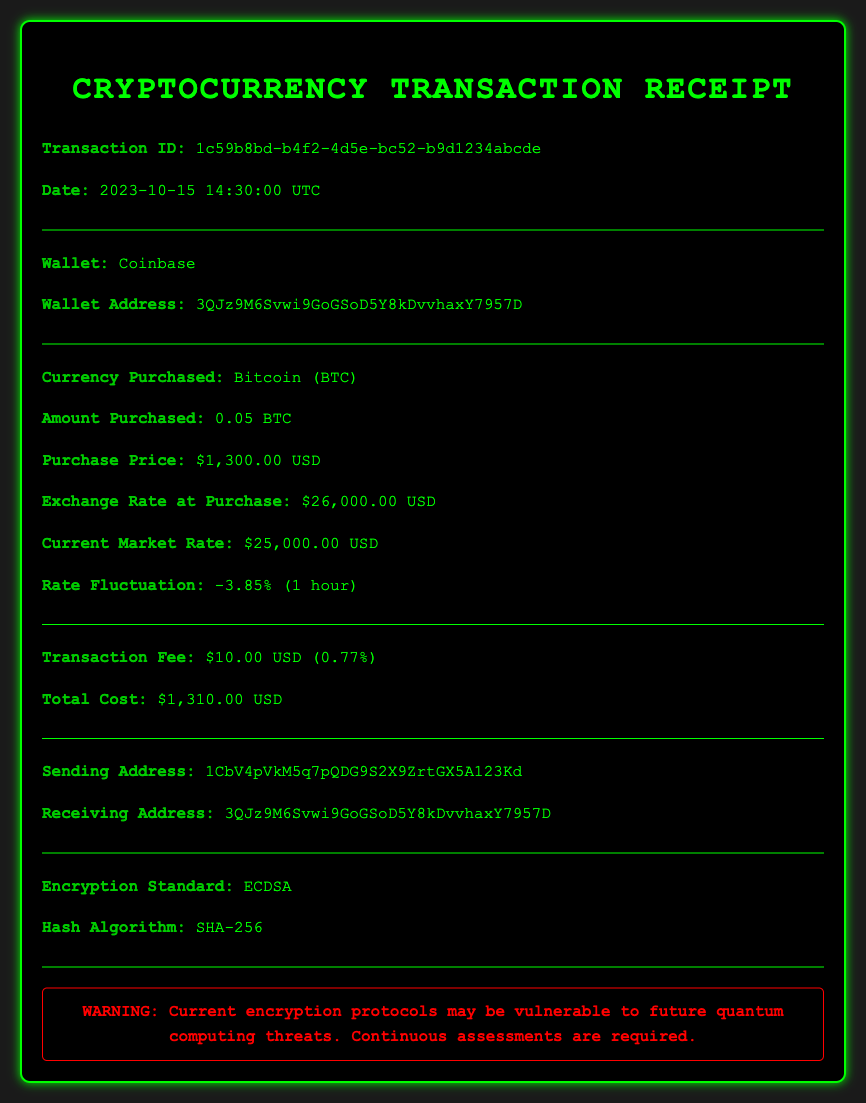What is the transaction ID? The transaction ID is a unique identifier for the transaction, located in the document.
Answer: 1c59b8bd-b4f2-4d5e-bc52-b9d1234abcde What is the amount purchased? The amount purchased refers to the quantity of cryptocurrency bought, which is detailed in the section about the currency purchased.
Answer: 0.05 BTC What is the purchase price? The purchase price is the cost associated with buying the cryptocurrency, which is clearly stated in the transaction details.
Answer: $1,300.00 USD What is the current market rate? The current market rate indicates the value of the cryptocurrency at the moment the document was generated, found in the section about currency values.
Answer: $25,000.00 USD What is the transaction fee percentage? The transaction fee percentage is calculated based on the total cost and is presented in the transaction fee section.
Answer: 0.77% What were the sending and receiving addresses? The sending and receiving addresses provide information about where the cryptocurrency is transferred to and from, located in their respective section.
Answer: 1CbV4pVkM5q7pQDG9S2X9ZrtGX5A123Kd and 3QJz9M6Svwi9GoGSoD5Y8kDvvhaxY7957D What is the rate fluctuation stated in the document? The rate fluctuation indicates the percentage change in value over a specific period and is mentioned in relation to the market rate.
Answer: -3.85% (1 hour) What encryption standard is mentioned? The encryption standard refers to the method used to secure the transaction, which is noted towards the end of the document.
Answer: ECDSA Why is there a warning about encryption protocols? The warning indicates a possible vulnerability of the current encryption standards to future threats, particularly from quantum computing.
Answer: Vulnerable to future quantum computing threats 